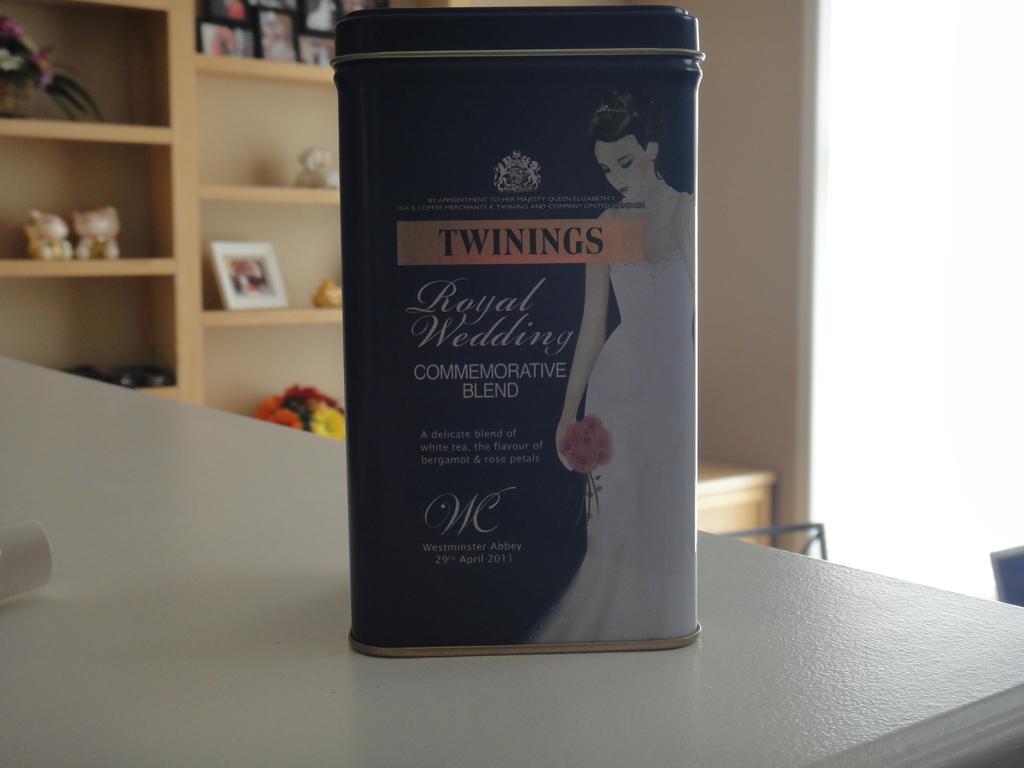What year was the commemorative blend of tea issued?
Give a very brief answer. 2011. What is the words in yellow?
Your answer should be compact. Twinings. 